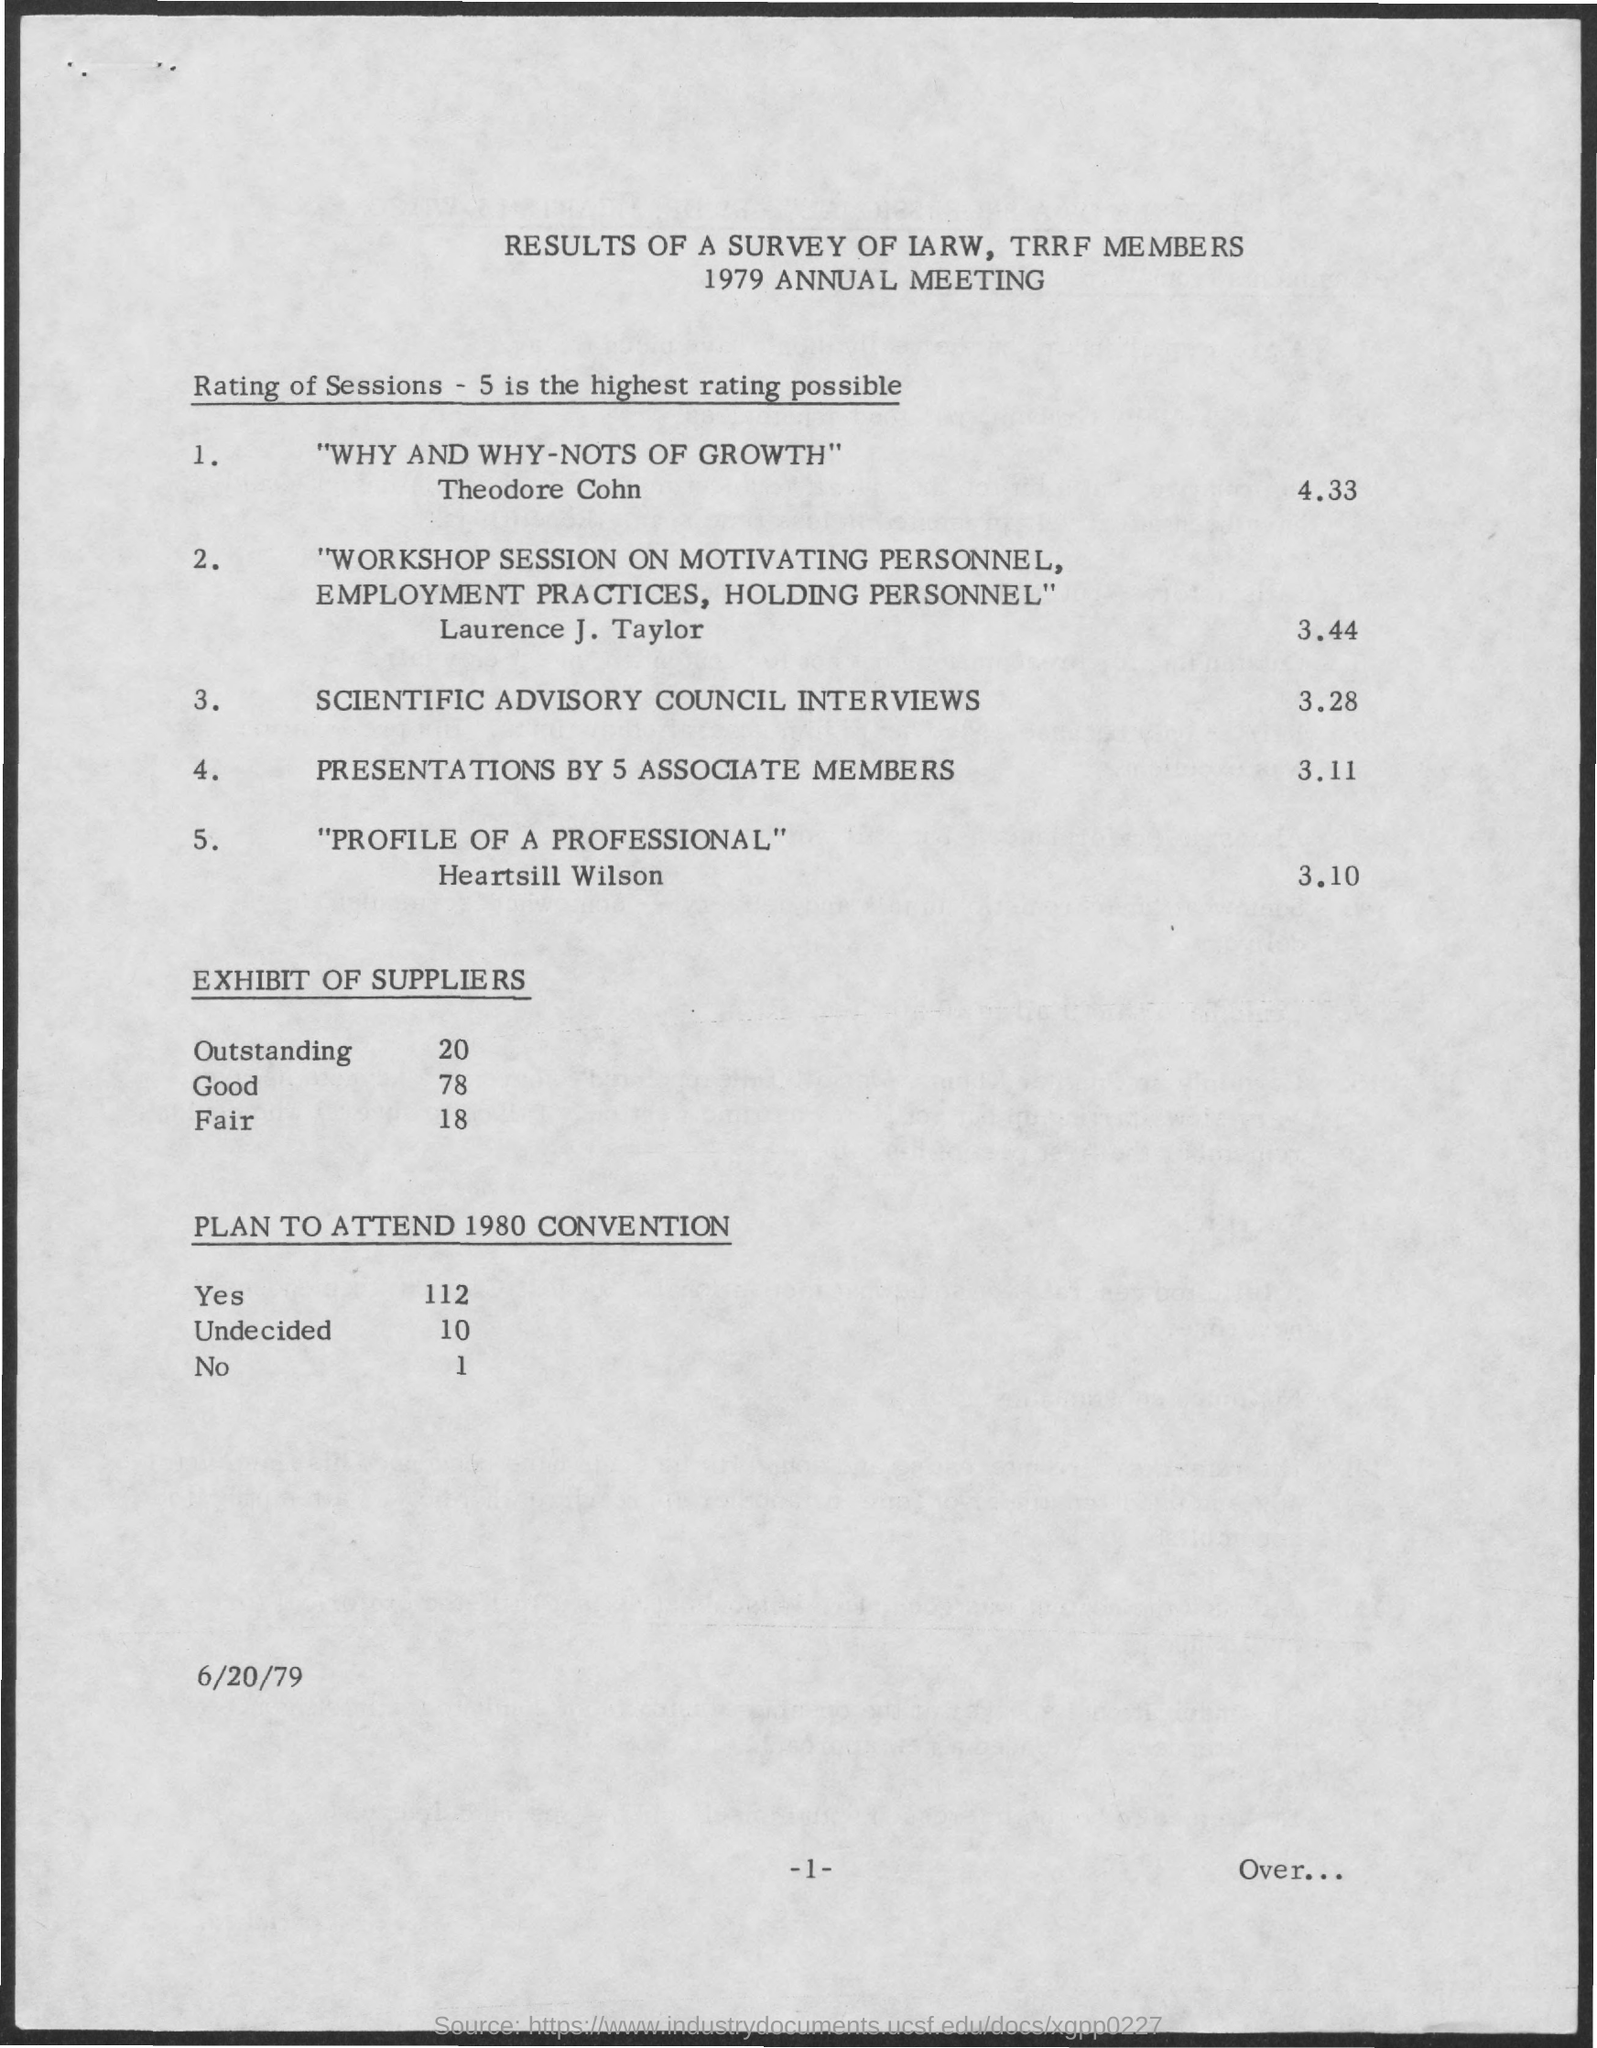Point out several critical features in this image. The document indicates that the date is June 20, 1979. It is estimated that approximately 1 person plans not to attend the 1980 convention. It is expected that 112 people will attend the 1980 convention. The page number is -1-.. The results of a survey of International Association of Radiation Oncology (IARW) and Technology and Research in Radiotherapy (TRRF) members have been obtained. 